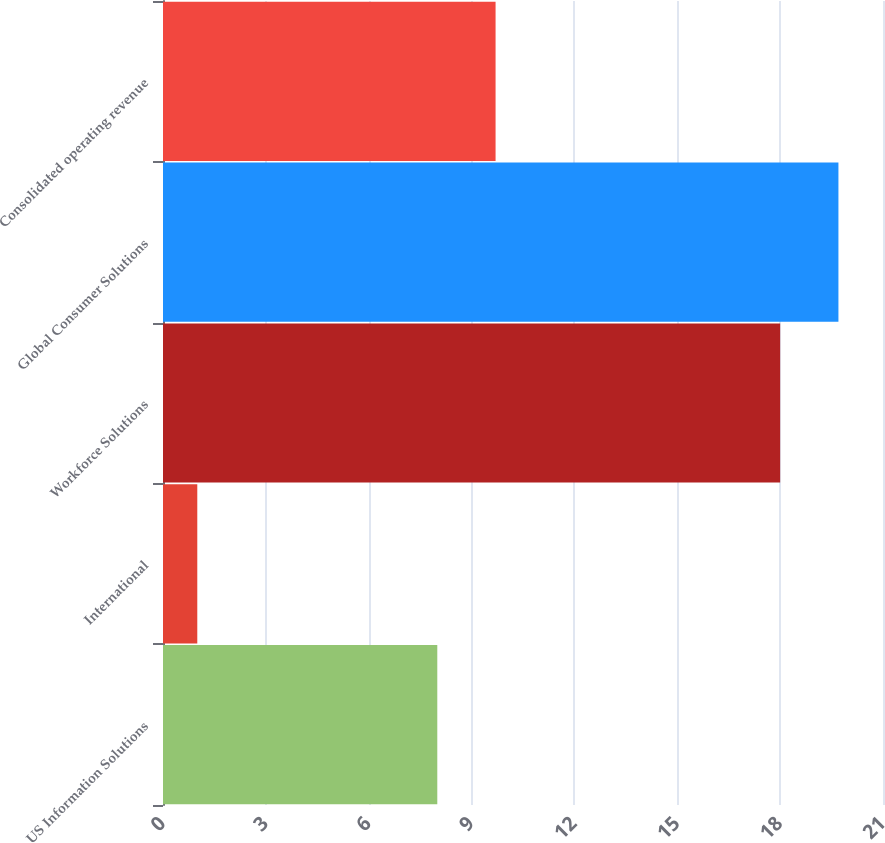Convert chart to OTSL. <chart><loc_0><loc_0><loc_500><loc_500><bar_chart><fcel>US Information Solutions<fcel>International<fcel>Workforce Solutions<fcel>Global Consumer Solutions<fcel>Consolidated operating revenue<nl><fcel>8<fcel>1<fcel>18<fcel>19.7<fcel>9.7<nl></chart> 